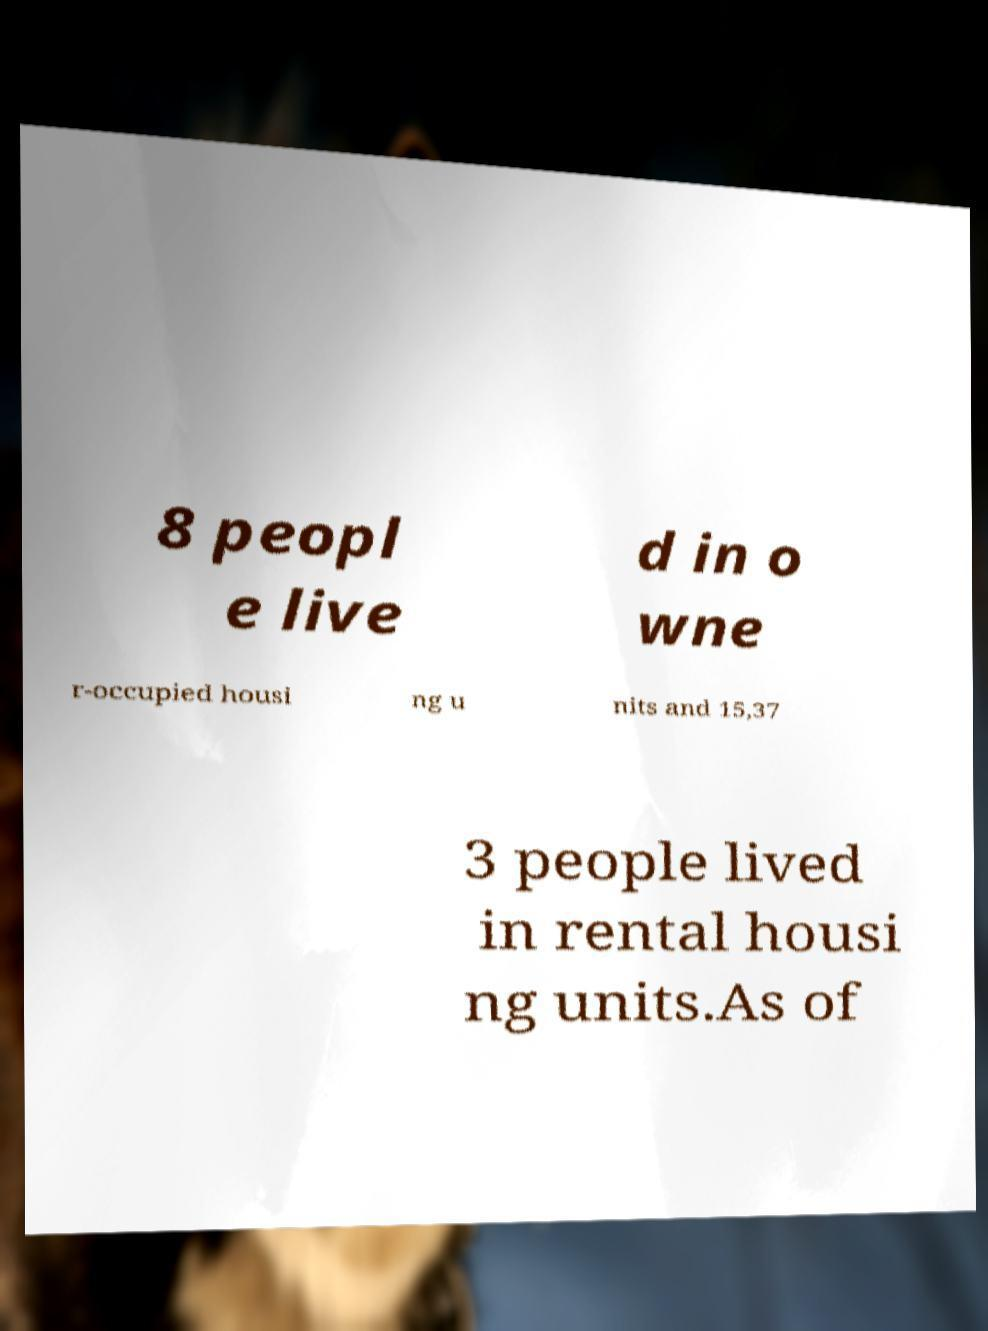Can you accurately transcribe the text from the provided image for me? 8 peopl e live d in o wne r-occupied housi ng u nits and 15,37 3 people lived in rental housi ng units.As of 